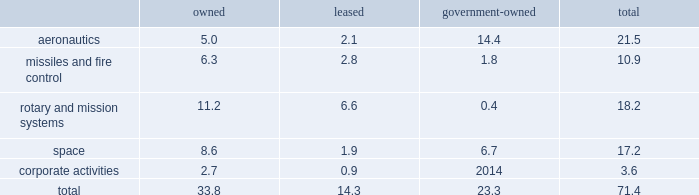Item 2 .
Properties at december 31 , 2017 , we owned or leased building space ( including offices , manufacturing plants , warehouses , service centers , laboratories and other facilities ) at approximately 375 locations primarily in the u.s .
Additionally , we manage or occupy approximately 15 government-owned facilities under lease and other arrangements .
At december 31 , 2017 , we had significant operations in the following locations : 2022 aeronautics - palmdale , california ; marietta , georgia ; greenville , south carolina ; and fort worth , texas .
2022 missiles and fire control - camdenarkansas ; ocala and orlando , florida ; lexington , kentucky ; and grand prairie , texas .
2022 rotary andmission systems - colorado springs , colorado ; shelton and stratford , connecticut ; orlando and jupiter , florida ; moorestown/mt .
Laurel , new jersey ; owego and syracuse , new york ; manassas , virginia ; and mielec , poland .
2022 space - sunnyvale , california ; denver , colorado ; valley forge , pennsylvania ; and reading , england .
2022 corporate activities - bethesda , maryland .
The following is a summary of our square feet of floor space by business segment at december 31 , 2017 ( in millions ) : owned leased government- owned total .
We believe our facilities are in good condition and adequate for their current use.wemay improve , replace or reduce facilities as considered appropriate to meet the needs of our operations .
Item 3 .
Legal proceedings we are a party to or have property subject to litigation and other proceedings that arise in the ordinary course of our business , including matters arising under provisions relating to the protection of the environment and are subject to contingencies related to certain businesses we previously owned .
These types of matters could result in fines , penalties , compensatory or treble damages or non-monetary sanctions or relief .
We believe the probability is remote that the outcome of each of these matters will have a material adverse effect on the corporation as a whole , notwithstanding that the unfavorable resolution of any matter may have a material effect on our net earnings in any particular interim reporting period .
We cannot predict the outcome of legal or other proceedings with certainty .
These matters include the proceedings summarized in 201cnote 14 2013 legal proceedings , commitments and contingencies 201d included in our notes to consolidated financial statements .
We are subject to federal , state , local and foreign requirements for protection of the environment , including those for discharge ofhazardousmaterials and remediationof contaminated sites.due inpart to thecomplexity andpervasivenessof these requirements , we are a party to or have property subject to various lawsuits , proceedings and remediation obligations .
The extent of our financial exposure cannot in all cases be reasonably estimated at this time .
For information regarding these matters , including current estimates of the amounts that we believe are required for remediation or clean-up to the extent estimable , see 201ccriticalaccounting policies - environmental matters 201d in management 2019s discussion and analysis of financial condition and results of operations and 201cnote 14 2013 legal proceedings , commitments andcontingencies 201d included in ournotes to consolidated financial statements .
As a u.s .
Government contractor , we are subject to various audits and investigations by the u.s .
Government to determine whetherouroperations arebeingconducted in accordancewith applicable regulatory requirements.u.s.government investigations of us , whether relating to government contracts or conducted for other reasons , could result in administrative , civil , or criminal liabilities , including repayments , fines or penalties being imposed upon us , suspension , proposed debarment , debarment from eligibility for future u.s .
Government contracting , or suspension of export privileges .
Suspension or debarment could have a material adverse effect on us because of our dependence on contracts with the u.s .
Government .
U.s .
Government investigations often take years to complete and many result in no adverse action against us .
We also provide products and services to customers outside of the u.s. , which are subject to u.s .
And foreign laws and regulations and foreign procurement policies and practices .
Our compliance with local regulations or applicable u.s .
Government regulations also may be audited or investigated .
Item 4 .
Mine safety disclosures not applicable. .
What percentage of square feet of floor space by business segment at december 31 , 2017 are in the aeronautics segment? 
Computations: (21.5 / 71.4)
Answer: 0.30112. 